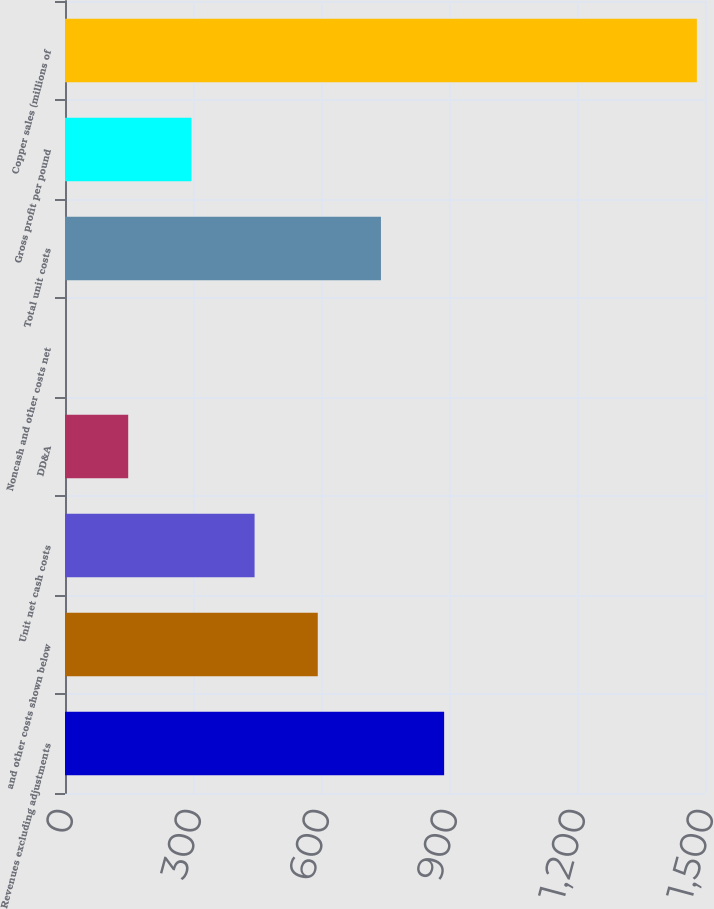<chart> <loc_0><loc_0><loc_500><loc_500><bar_chart><fcel>Revenues excluding adjustments<fcel>and other costs shown below<fcel>Unit net cash costs<fcel>DD&A<fcel>Noncash and other costs net<fcel>Total unit costs<fcel>Gross profit per pound<fcel>Copper sales (millions of<nl><fcel>888.6<fcel>592.42<fcel>444.33<fcel>148.15<fcel>0.06<fcel>740.51<fcel>296.24<fcel>1481<nl></chart> 